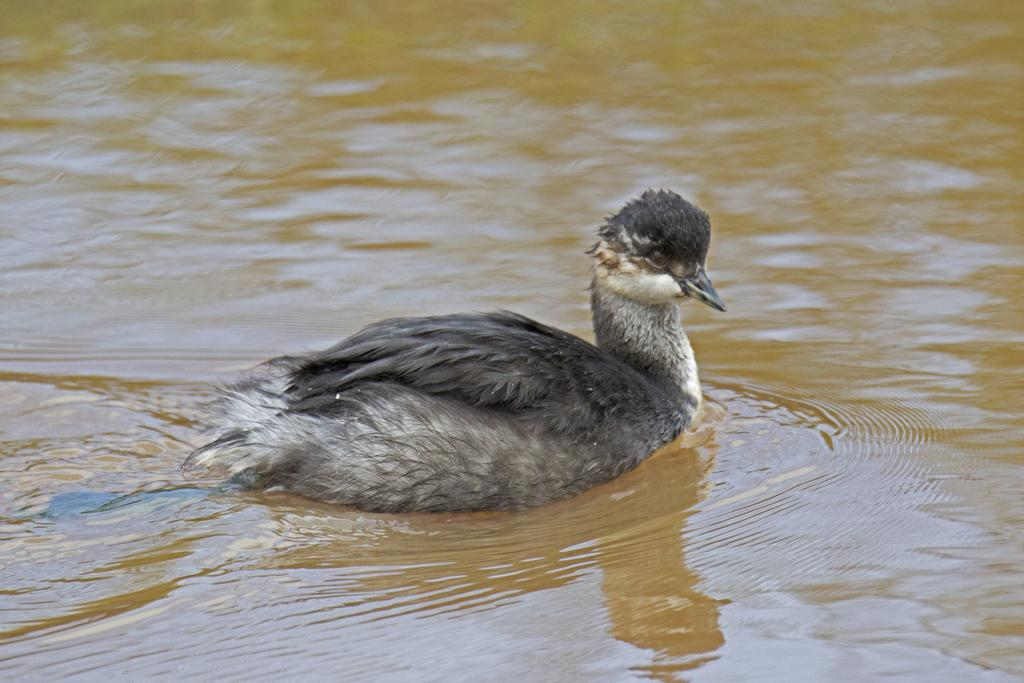What is the main subject in the center of the image? There is a bird in the center of the image. What can be seen at the bottom of the image? There is a river at the bottom of the image. What type of degree does the bird have in the image? There is no indication in the image that the bird has a degree, as birds do not obtain degrees. 